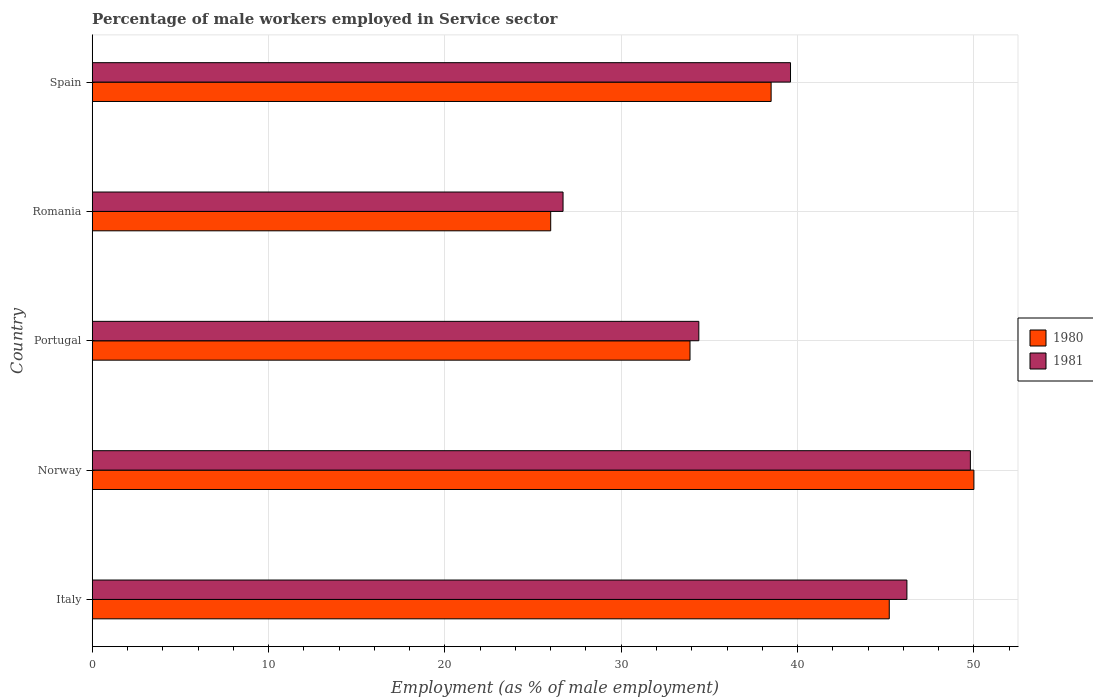How many different coloured bars are there?
Give a very brief answer. 2. How many groups of bars are there?
Your answer should be very brief. 5. Are the number of bars per tick equal to the number of legend labels?
Offer a terse response. Yes. Are the number of bars on each tick of the Y-axis equal?
Keep it short and to the point. Yes. How many bars are there on the 3rd tick from the bottom?
Keep it short and to the point. 2. What is the label of the 5th group of bars from the top?
Provide a short and direct response. Italy. In how many cases, is the number of bars for a given country not equal to the number of legend labels?
Your response must be concise. 0. What is the percentage of male workers employed in Service sector in 1980 in Norway?
Give a very brief answer. 50. Across all countries, what is the maximum percentage of male workers employed in Service sector in 1981?
Make the answer very short. 49.8. Across all countries, what is the minimum percentage of male workers employed in Service sector in 1980?
Offer a terse response. 26. In which country was the percentage of male workers employed in Service sector in 1981 maximum?
Your answer should be compact. Norway. In which country was the percentage of male workers employed in Service sector in 1981 minimum?
Offer a terse response. Romania. What is the total percentage of male workers employed in Service sector in 1981 in the graph?
Make the answer very short. 196.7. What is the difference between the percentage of male workers employed in Service sector in 1980 in Italy and that in Spain?
Offer a terse response. 6.7. What is the difference between the percentage of male workers employed in Service sector in 1980 in Italy and the percentage of male workers employed in Service sector in 1981 in Romania?
Ensure brevity in your answer.  18.5. What is the average percentage of male workers employed in Service sector in 1981 per country?
Your answer should be compact. 39.34. What is the difference between the percentage of male workers employed in Service sector in 1981 and percentage of male workers employed in Service sector in 1980 in Norway?
Your answer should be very brief. -0.2. What is the ratio of the percentage of male workers employed in Service sector in 1981 in Italy to that in Portugal?
Your answer should be very brief. 1.34. Is the percentage of male workers employed in Service sector in 1980 in Portugal less than that in Spain?
Provide a succinct answer. Yes. What is the difference between the highest and the second highest percentage of male workers employed in Service sector in 1980?
Your response must be concise. 4.8. In how many countries, is the percentage of male workers employed in Service sector in 1981 greater than the average percentage of male workers employed in Service sector in 1981 taken over all countries?
Ensure brevity in your answer.  3. What does the 1st bar from the top in Spain represents?
Offer a very short reply. 1981. What does the 2nd bar from the bottom in Italy represents?
Provide a succinct answer. 1981. How many bars are there?
Your answer should be very brief. 10. How many countries are there in the graph?
Provide a succinct answer. 5. Does the graph contain grids?
Provide a short and direct response. Yes. How many legend labels are there?
Provide a succinct answer. 2. How are the legend labels stacked?
Offer a terse response. Vertical. What is the title of the graph?
Provide a short and direct response. Percentage of male workers employed in Service sector. Does "1987" appear as one of the legend labels in the graph?
Your response must be concise. No. What is the label or title of the X-axis?
Ensure brevity in your answer.  Employment (as % of male employment). What is the label or title of the Y-axis?
Make the answer very short. Country. What is the Employment (as % of male employment) in 1980 in Italy?
Your answer should be very brief. 45.2. What is the Employment (as % of male employment) of 1981 in Italy?
Provide a short and direct response. 46.2. What is the Employment (as % of male employment) in 1981 in Norway?
Offer a terse response. 49.8. What is the Employment (as % of male employment) of 1980 in Portugal?
Offer a very short reply. 33.9. What is the Employment (as % of male employment) in 1981 in Portugal?
Your response must be concise. 34.4. What is the Employment (as % of male employment) in 1981 in Romania?
Provide a succinct answer. 26.7. What is the Employment (as % of male employment) in 1980 in Spain?
Your answer should be compact. 38.5. What is the Employment (as % of male employment) in 1981 in Spain?
Keep it short and to the point. 39.6. Across all countries, what is the maximum Employment (as % of male employment) of 1981?
Provide a short and direct response. 49.8. Across all countries, what is the minimum Employment (as % of male employment) of 1981?
Your answer should be compact. 26.7. What is the total Employment (as % of male employment) in 1980 in the graph?
Your response must be concise. 193.6. What is the total Employment (as % of male employment) of 1981 in the graph?
Keep it short and to the point. 196.7. What is the difference between the Employment (as % of male employment) of 1981 in Italy and that in Norway?
Keep it short and to the point. -3.6. What is the difference between the Employment (as % of male employment) in 1980 in Italy and that in Portugal?
Ensure brevity in your answer.  11.3. What is the difference between the Employment (as % of male employment) of 1981 in Italy and that in Portugal?
Make the answer very short. 11.8. What is the difference between the Employment (as % of male employment) of 1980 in Italy and that in Romania?
Give a very brief answer. 19.2. What is the difference between the Employment (as % of male employment) of 1980 in Italy and that in Spain?
Provide a short and direct response. 6.7. What is the difference between the Employment (as % of male employment) in 1981 in Italy and that in Spain?
Provide a short and direct response. 6.6. What is the difference between the Employment (as % of male employment) in 1980 in Norway and that in Portugal?
Keep it short and to the point. 16.1. What is the difference between the Employment (as % of male employment) in 1981 in Norway and that in Romania?
Offer a terse response. 23.1. What is the difference between the Employment (as % of male employment) in 1981 in Norway and that in Spain?
Give a very brief answer. 10.2. What is the difference between the Employment (as % of male employment) in 1981 in Portugal and that in Romania?
Give a very brief answer. 7.7. What is the difference between the Employment (as % of male employment) in 1980 in Portugal and that in Spain?
Provide a succinct answer. -4.6. What is the difference between the Employment (as % of male employment) in 1980 in Romania and that in Spain?
Your answer should be very brief. -12.5. What is the difference between the Employment (as % of male employment) of 1980 in Italy and the Employment (as % of male employment) of 1981 in Romania?
Provide a succinct answer. 18.5. What is the difference between the Employment (as % of male employment) in 1980 in Italy and the Employment (as % of male employment) in 1981 in Spain?
Your response must be concise. 5.6. What is the difference between the Employment (as % of male employment) in 1980 in Norway and the Employment (as % of male employment) in 1981 in Portugal?
Your response must be concise. 15.6. What is the difference between the Employment (as % of male employment) of 1980 in Norway and the Employment (as % of male employment) of 1981 in Romania?
Your answer should be very brief. 23.3. What is the difference between the Employment (as % of male employment) of 1980 in Norway and the Employment (as % of male employment) of 1981 in Spain?
Make the answer very short. 10.4. What is the difference between the Employment (as % of male employment) of 1980 in Romania and the Employment (as % of male employment) of 1981 in Spain?
Keep it short and to the point. -13.6. What is the average Employment (as % of male employment) of 1980 per country?
Your response must be concise. 38.72. What is the average Employment (as % of male employment) of 1981 per country?
Your answer should be very brief. 39.34. What is the difference between the Employment (as % of male employment) of 1980 and Employment (as % of male employment) of 1981 in Portugal?
Offer a terse response. -0.5. What is the difference between the Employment (as % of male employment) in 1980 and Employment (as % of male employment) in 1981 in Romania?
Give a very brief answer. -0.7. What is the difference between the Employment (as % of male employment) of 1980 and Employment (as % of male employment) of 1981 in Spain?
Provide a succinct answer. -1.1. What is the ratio of the Employment (as % of male employment) of 1980 in Italy to that in Norway?
Your answer should be very brief. 0.9. What is the ratio of the Employment (as % of male employment) in 1981 in Italy to that in Norway?
Keep it short and to the point. 0.93. What is the ratio of the Employment (as % of male employment) of 1981 in Italy to that in Portugal?
Your answer should be compact. 1.34. What is the ratio of the Employment (as % of male employment) in 1980 in Italy to that in Romania?
Give a very brief answer. 1.74. What is the ratio of the Employment (as % of male employment) of 1981 in Italy to that in Romania?
Your answer should be very brief. 1.73. What is the ratio of the Employment (as % of male employment) in 1980 in Italy to that in Spain?
Make the answer very short. 1.17. What is the ratio of the Employment (as % of male employment) in 1981 in Italy to that in Spain?
Make the answer very short. 1.17. What is the ratio of the Employment (as % of male employment) of 1980 in Norway to that in Portugal?
Ensure brevity in your answer.  1.47. What is the ratio of the Employment (as % of male employment) of 1981 in Norway to that in Portugal?
Ensure brevity in your answer.  1.45. What is the ratio of the Employment (as % of male employment) of 1980 in Norway to that in Romania?
Ensure brevity in your answer.  1.92. What is the ratio of the Employment (as % of male employment) of 1981 in Norway to that in Romania?
Provide a short and direct response. 1.87. What is the ratio of the Employment (as % of male employment) of 1980 in Norway to that in Spain?
Your answer should be very brief. 1.3. What is the ratio of the Employment (as % of male employment) of 1981 in Norway to that in Spain?
Provide a succinct answer. 1.26. What is the ratio of the Employment (as % of male employment) in 1980 in Portugal to that in Romania?
Ensure brevity in your answer.  1.3. What is the ratio of the Employment (as % of male employment) of 1981 in Portugal to that in Romania?
Ensure brevity in your answer.  1.29. What is the ratio of the Employment (as % of male employment) of 1980 in Portugal to that in Spain?
Make the answer very short. 0.88. What is the ratio of the Employment (as % of male employment) of 1981 in Portugal to that in Spain?
Make the answer very short. 0.87. What is the ratio of the Employment (as % of male employment) in 1980 in Romania to that in Spain?
Offer a terse response. 0.68. What is the ratio of the Employment (as % of male employment) of 1981 in Romania to that in Spain?
Offer a terse response. 0.67. What is the difference between the highest and the second highest Employment (as % of male employment) in 1981?
Give a very brief answer. 3.6. What is the difference between the highest and the lowest Employment (as % of male employment) of 1981?
Provide a short and direct response. 23.1. 